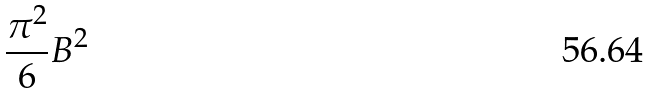<formula> <loc_0><loc_0><loc_500><loc_500>\frac { \pi ^ { 2 } } { 6 } B ^ { 2 }</formula> 